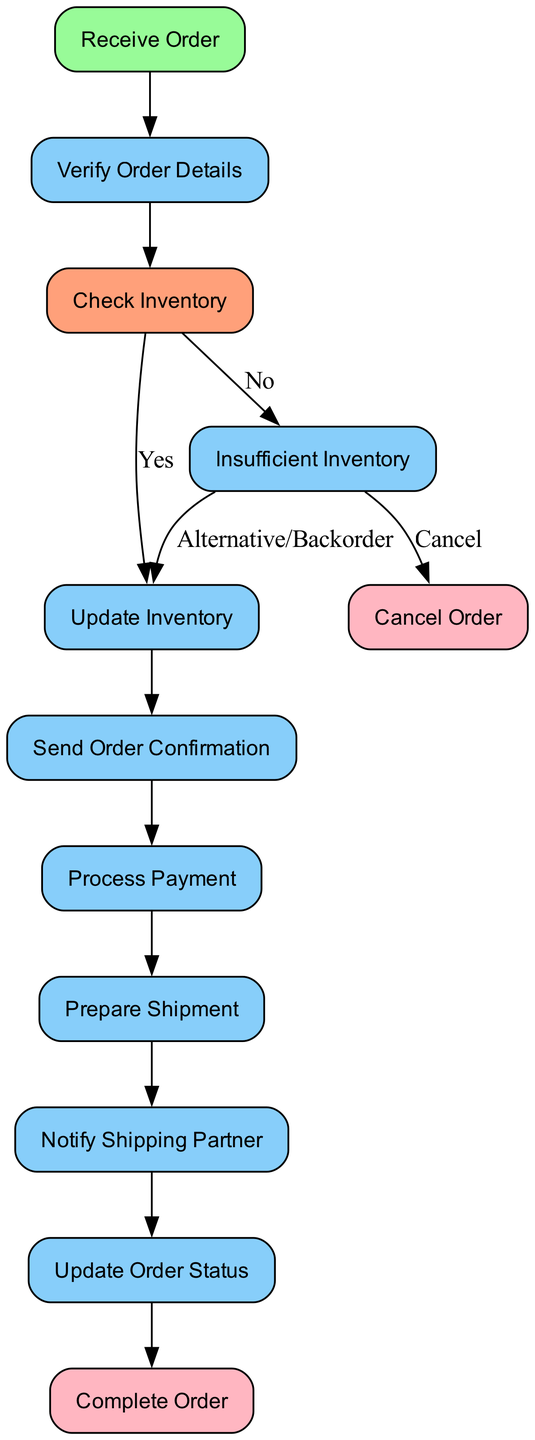What is the starting point of the order processing flow? The starting point of the order processing flow is the "Receive Order" node, where the customer places an order.
Answer: Receive Order How many decision points are present in the flowchart? There is one decision point in the flowchart: "Check Inventory", which determines if items are available or not.
Answer: 1 What happens when inventory is insufficient? When inventory is insufficient, the system notifies the customer about unavailability and offers alternatives or backorder options.
Answer: Notify the customer What is the final step if the order is canceled? If the order is canceled, the final step in the process is "Cancel Order", which terminates the order processing.
Answer: Cancel Order What action occurs after updating the inventory? After updating the inventory, the next action is to "Send Order Confirmation" to the customer.
Answer: Send Order Confirmation How many process nodes are there in total? There are eight process nodes in total in the flowchart, including receiving the order, verifying details, updating inventory, etc.
Answer: 8 What is the pathway if the inventory check is positive? If the inventory check is positive, the process flows from "Check Inventory" to "Update Inventory" and continues to process payment and prepare shipment.
Answer: Update Inventory Which step informs the shipping partner about the order? The step that informs the shipping partner about the order is "Notify Shipping Partner".
Answer: Notify Shipping Partner 